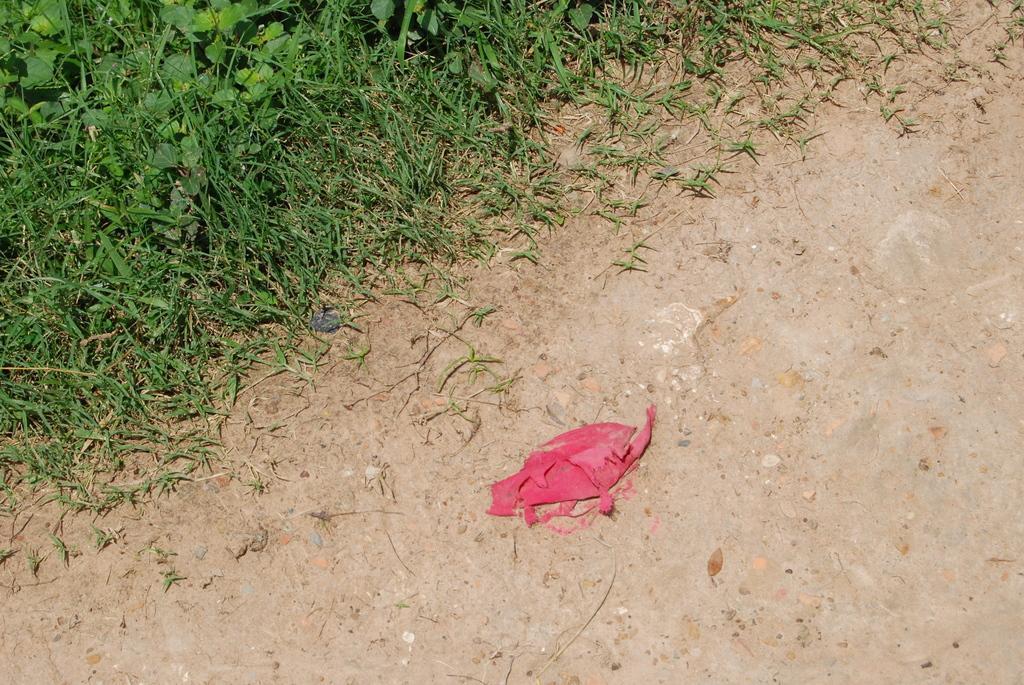Please provide a concise description of this image. In the foreground of this image, there is a red color cloth like an object on the ground. At the top, there is grass. 